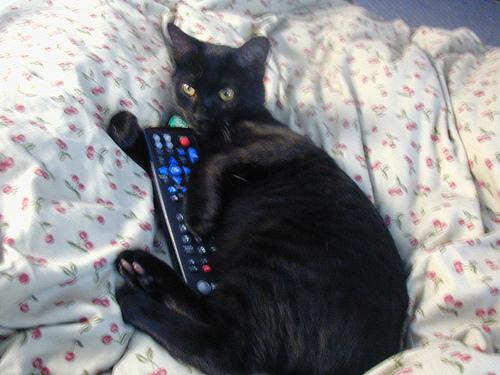Does the cat watch TV?
Give a very brief answer. Yes. What design is on the sheet the cat is laying on?
Concise answer only. Cherries. What is the cat holding?
Write a very short answer. Remote. 